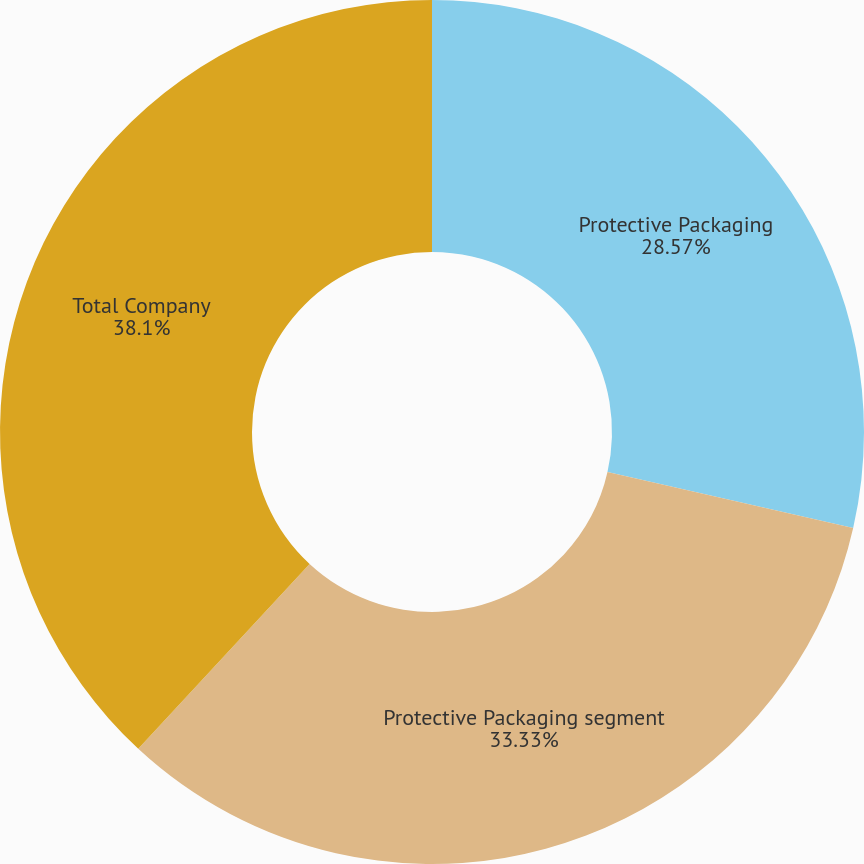<chart> <loc_0><loc_0><loc_500><loc_500><pie_chart><fcel>Protective Packaging<fcel>Protective Packaging segment<fcel>Total Company<nl><fcel>28.57%<fcel>33.33%<fcel>38.1%<nl></chart> 